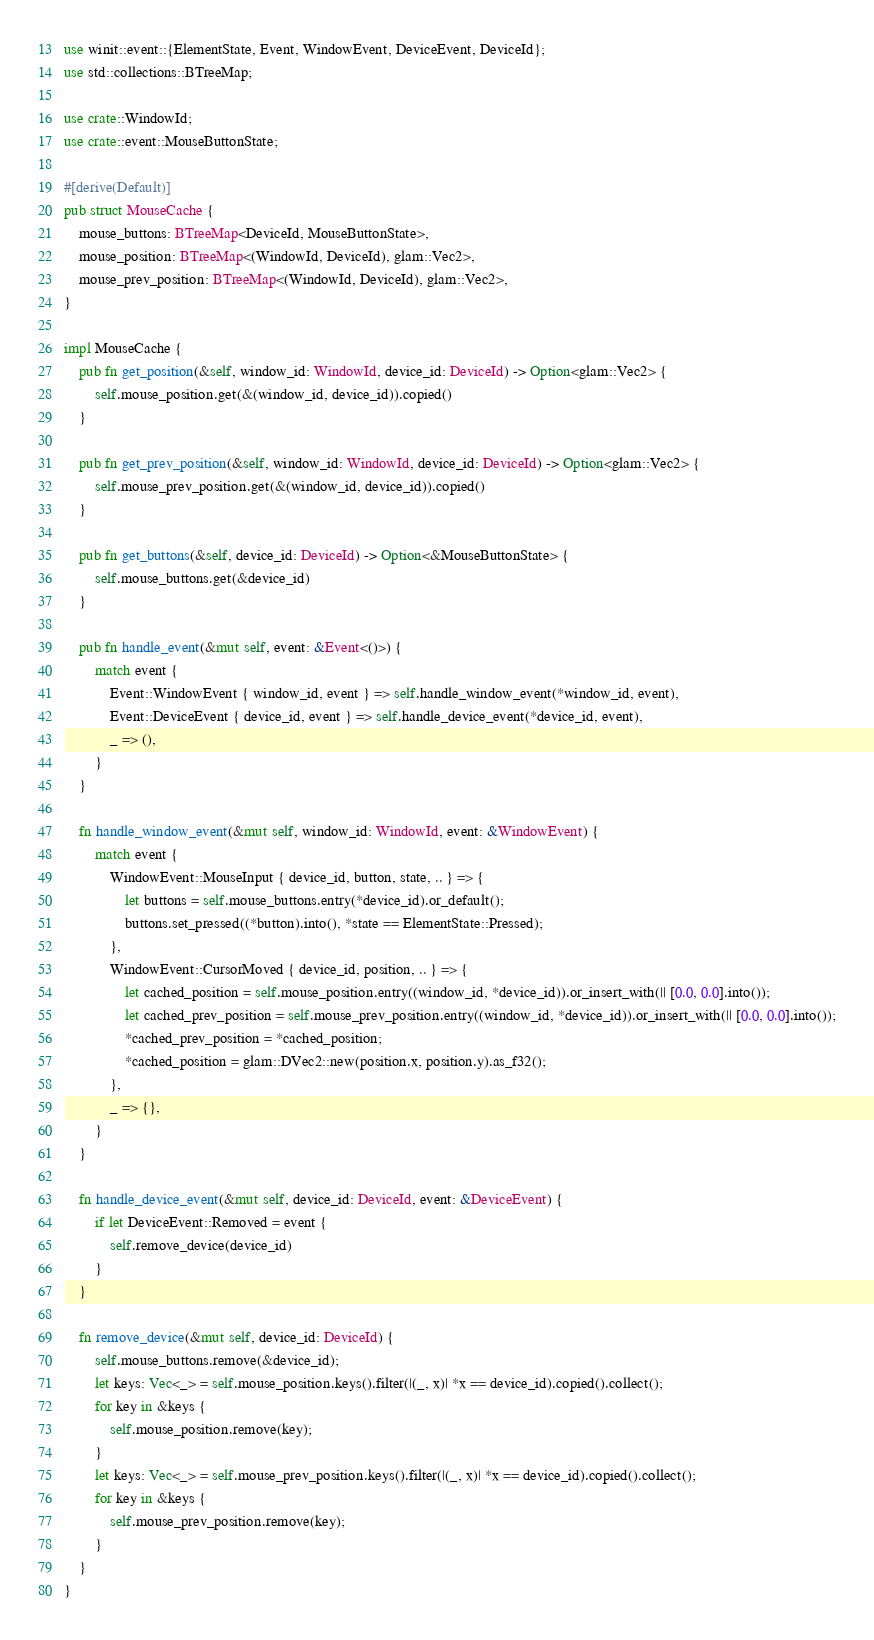Convert code to text. <code><loc_0><loc_0><loc_500><loc_500><_Rust_>use winit::event::{ElementState, Event, WindowEvent, DeviceEvent, DeviceId};
use std::collections::BTreeMap;

use crate::WindowId;
use crate::event::MouseButtonState;

#[derive(Default)]
pub struct MouseCache {
	mouse_buttons: BTreeMap<DeviceId, MouseButtonState>,
	mouse_position: BTreeMap<(WindowId, DeviceId), glam::Vec2>,
	mouse_prev_position: BTreeMap<(WindowId, DeviceId), glam::Vec2>,
}

impl MouseCache {
	pub fn get_position(&self, window_id: WindowId, device_id: DeviceId) -> Option<glam::Vec2> {
		self.mouse_position.get(&(window_id, device_id)).copied()
	}

	pub fn get_prev_position(&self, window_id: WindowId, device_id: DeviceId) -> Option<glam::Vec2> {
		self.mouse_prev_position.get(&(window_id, device_id)).copied()
	}

	pub fn get_buttons(&self, device_id: DeviceId) -> Option<&MouseButtonState> {
		self.mouse_buttons.get(&device_id)
	}

	pub fn handle_event(&mut self, event: &Event<()>) {
		match event {
			Event::WindowEvent { window_id, event } => self.handle_window_event(*window_id, event),
			Event::DeviceEvent { device_id, event } => self.handle_device_event(*device_id, event),
			_ => (),
		}
	}

	fn handle_window_event(&mut self, window_id: WindowId, event: &WindowEvent) {
		match event {
			WindowEvent::MouseInput { device_id, button, state, .. } => {
				let buttons = self.mouse_buttons.entry(*device_id).or_default();
				buttons.set_pressed((*button).into(), *state == ElementState::Pressed);
			},
			WindowEvent::CursorMoved { device_id, position, .. } => {
				let cached_position = self.mouse_position.entry((window_id, *device_id)).or_insert_with(|| [0.0, 0.0].into());
				let cached_prev_position = self.mouse_prev_position.entry((window_id, *device_id)).or_insert_with(|| [0.0, 0.0].into());
				*cached_prev_position = *cached_position;
				*cached_position = glam::DVec2::new(position.x, position.y).as_f32();
			},
			_ => {},
		}
	}

	fn handle_device_event(&mut self, device_id: DeviceId, event: &DeviceEvent) {
		if let DeviceEvent::Removed = event {
			self.remove_device(device_id)
		}
	}

	fn remove_device(&mut self, device_id: DeviceId) {
		self.mouse_buttons.remove(&device_id);
		let keys: Vec<_> = self.mouse_position.keys().filter(|(_, x)| *x == device_id).copied().collect();
		for key in &keys {
			self.mouse_position.remove(key);
		}
		let keys: Vec<_> = self.mouse_prev_position.keys().filter(|(_, x)| *x == device_id).copied().collect();
		for key in &keys {
			self.mouse_prev_position.remove(key);
		}
	}
}
</code> 